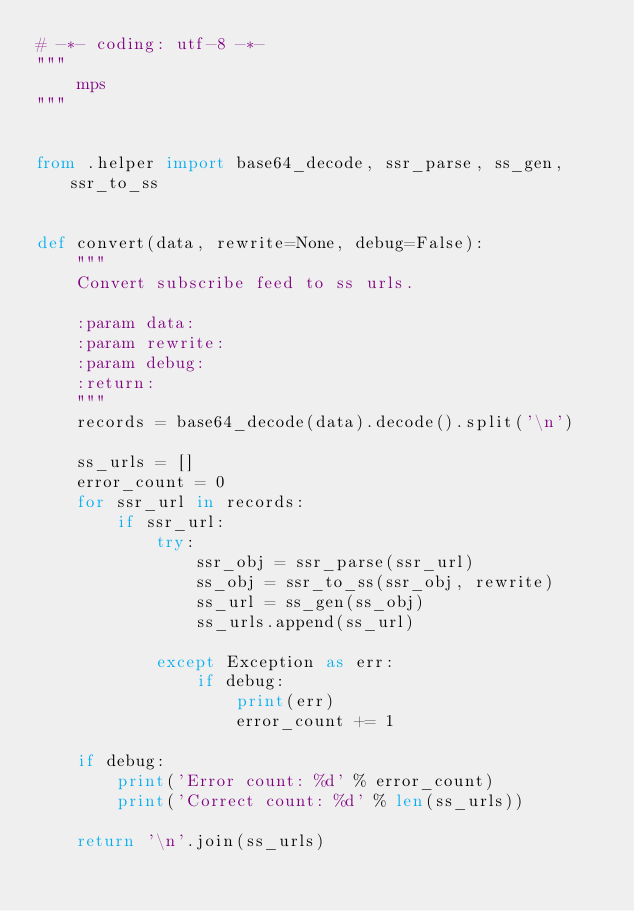<code> <loc_0><loc_0><loc_500><loc_500><_Python_># -*- coding: utf-8 -*-
"""
    mps
"""


from .helper import base64_decode, ssr_parse, ss_gen, ssr_to_ss


def convert(data, rewrite=None, debug=False):
    """
    Convert subscribe feed to ss urls.

    :param data:
    :param rewrite:
    :param debug:
    :return:
    """
    records = base64_decode(data).decode().split('\n')

    ss_urls = []
    error_count = 0
    for ssr_url in records:
        if ssr_url:
            try:
                ssr_obj = ssr_parse(ssr_url)
                ss_obj = ssr_to_ss(ssr_obj, rewrite)
                ss_url = ss_gen(ss_obj)
                ss_urls.append(ss_url)

            except Exception as err:
                if debug:
                    print(err)
                    error_count += 1

    if debug:
        print('Error count: %d' % error_count)
        print('Correct count: %d' % len(ss_urls))

    return '\n'.join(ss_urls)
</code> 